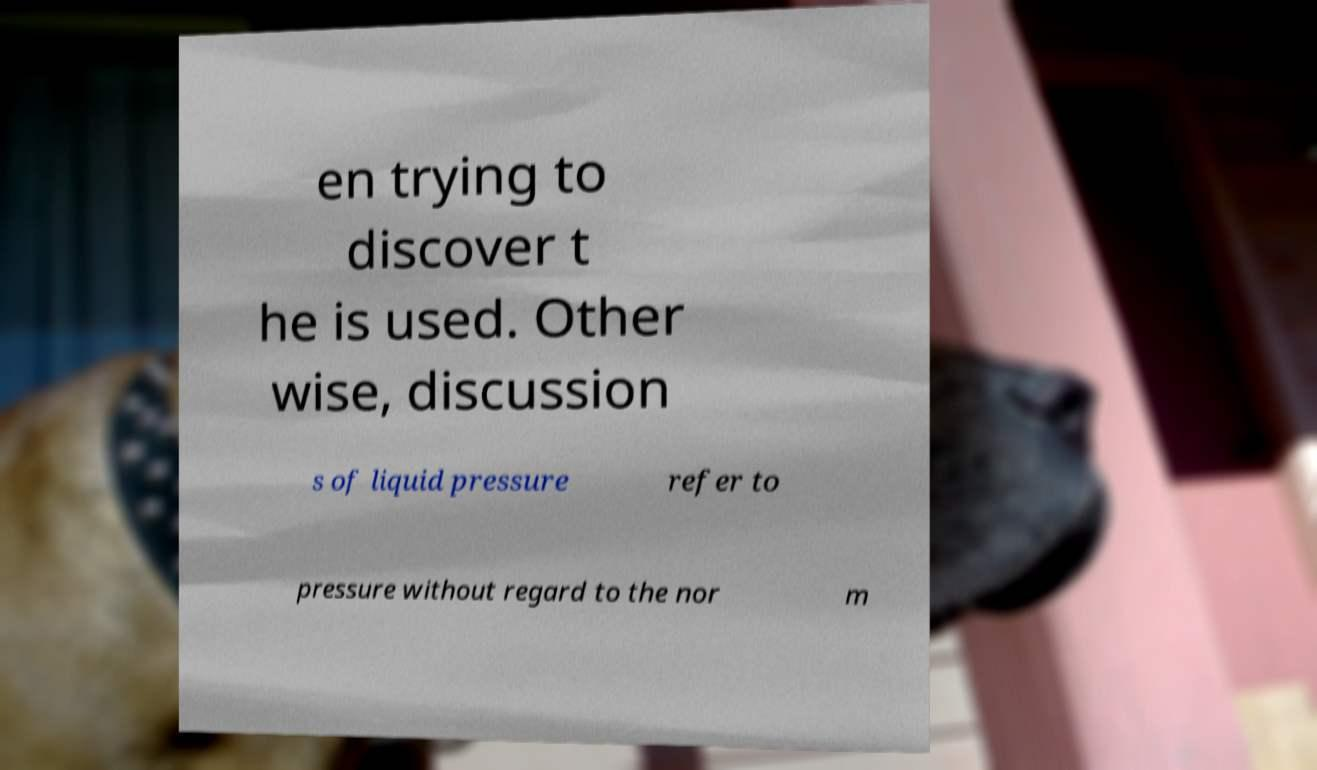I need the written content from this picture converted into text. Can you do that? en trying to discover t he is used. Other wise, discussion s of liquid pressure refer to pressure without regard to the nor m 